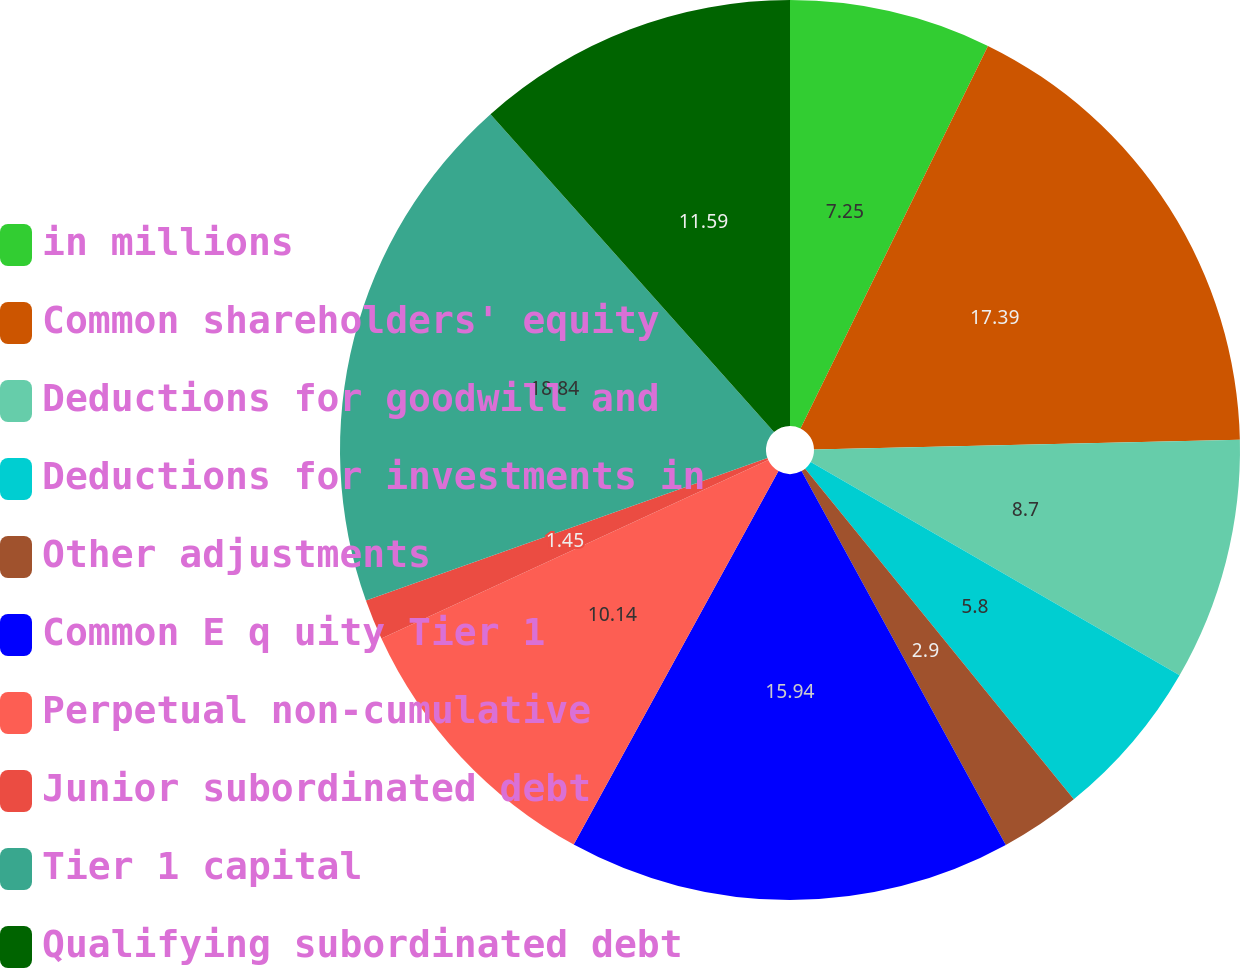<chart> <loc_0><loc_0><loc_500><loc_500><pie_chart><fcel>in millions<fcel>Common shareholders' equity<fcel>Deductions for goodwill and<fcel>Deductions for investments in<fcel>Other adjustments<fcel>Common E q uity Tier 1<fcel>Perpetual non-cumulative<fcel>Junior subordinated debt<fcel>Tier 1 capital<fcel>Qualifying subordinated debt<nl><fcel>7.25%<fcel>17.39%<fcel>8.7%<fcel>5.8%<fcel>2.9%<fcel>15.94%<fcel>10.14%<fcel>1.45%<fcel>18.84%<fcel>11.59%<nl></chart> 